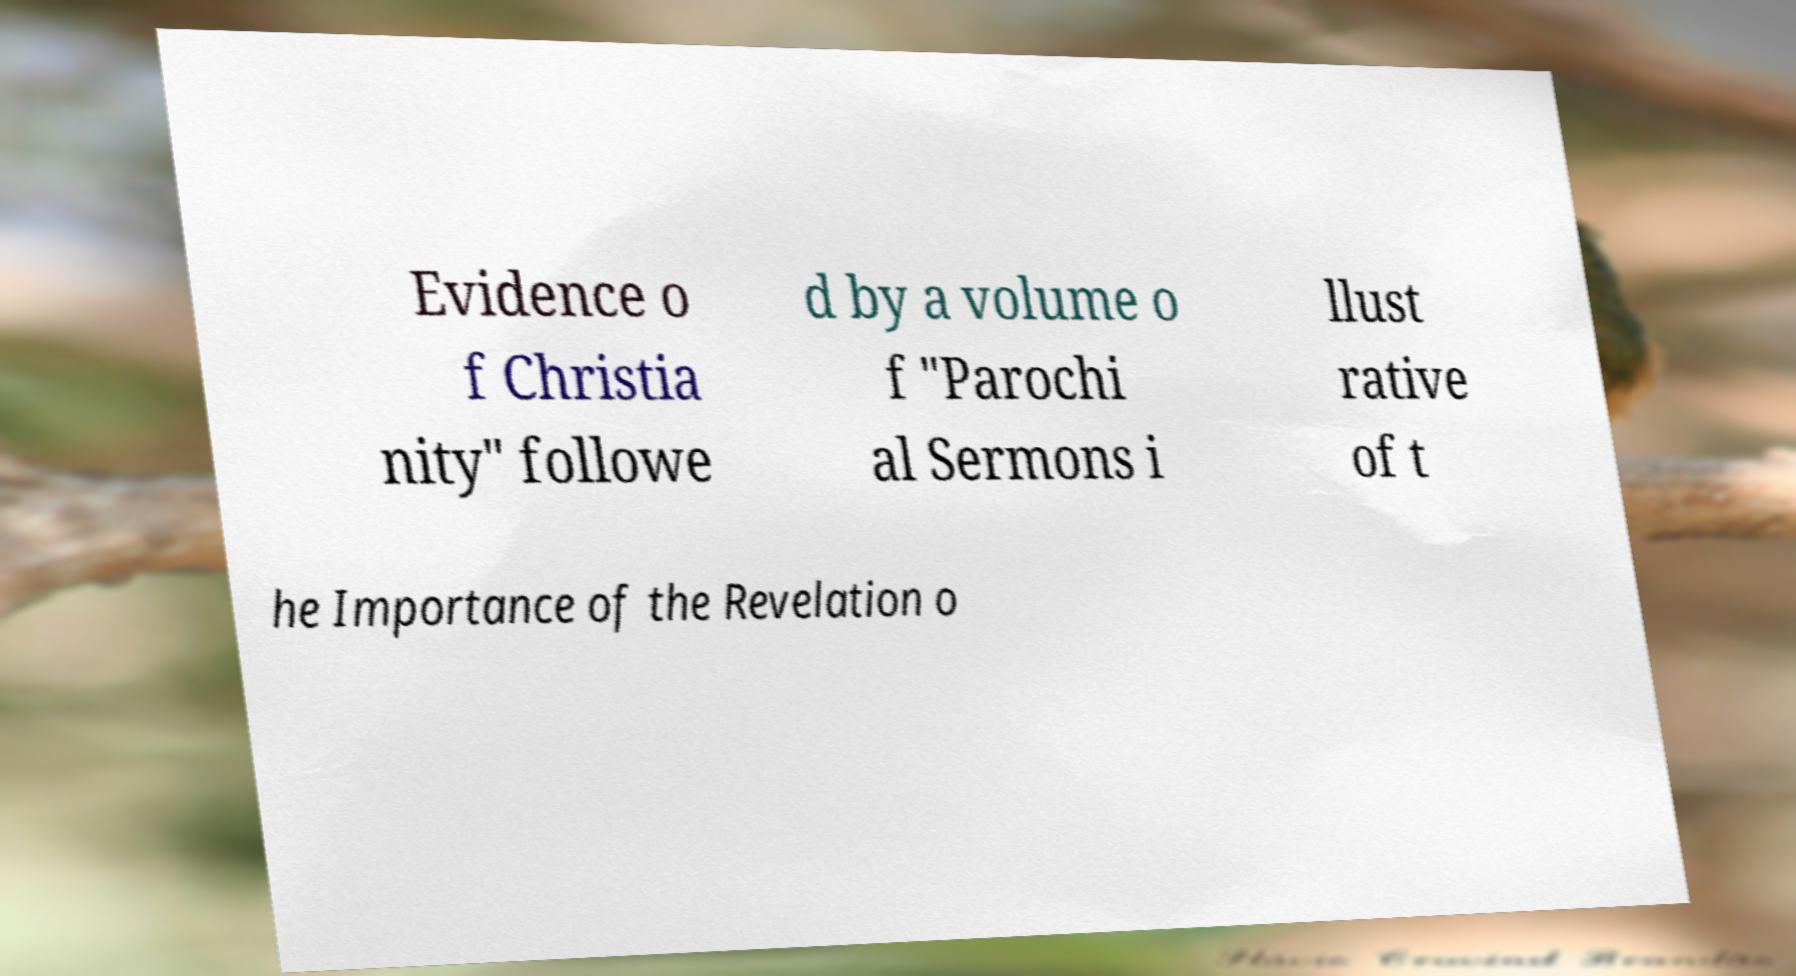Could you assist in decoding the text presented in this image and type it out clearly? Evidence o f Christia nity" followe d by a volume o f "Parochi al Sermons i llust rative of t he Importance of the Revelation o 